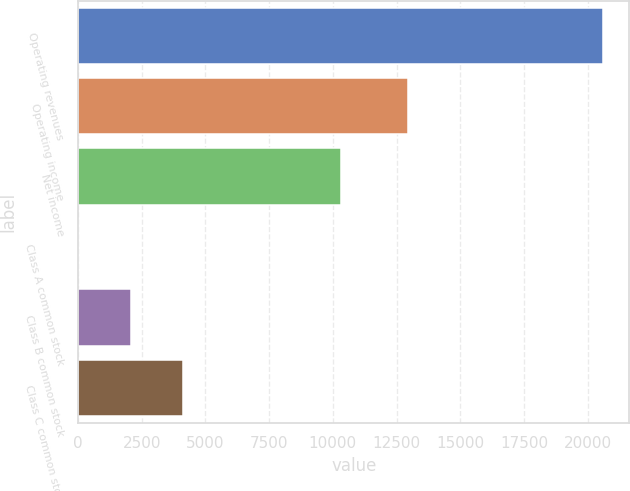<chart> <loc_0><loc_0><loc_500><loc_500><bar_chart><fcel>Operating revenues<fcel>Operating income<fcel>Net income<fcel>Class A common stock<fcel>Class B common stock<fcel>Class C common stock<nl><fcel>20609<fcel>12954<fcel>10301<fcel>4.43<fcel>2064.89<fcel>4125.35<nl></chart> 